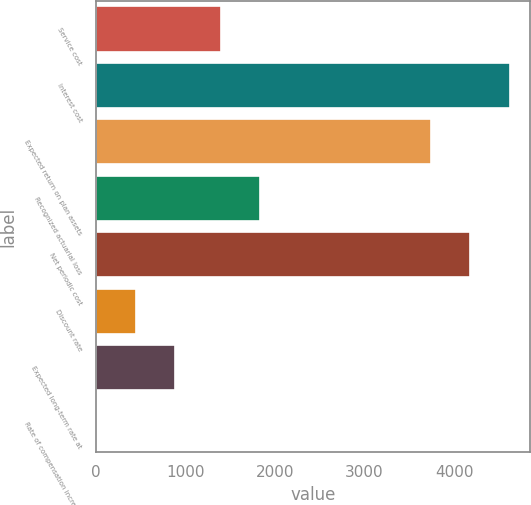Convert chart to OTSL. <chart><loc_0><loc_0><loc_500><loc_500><bar_chart><fcel>Service cost<fcel>Interest cost<fcel>Expected return on plan assets<fcel>Recognized actuarial loss<fcel>Net periodic cost<fcel>Discount rate<fcel>Expected long-term rate at<fcel>Rate of compensation increase<nl><fcel>1393<fcel>4620.8<fcel>3742<fcel>1832.4<fcel>4181.4<fcel>443.4<fcel>882.8<fcel>4<nl></chart> 